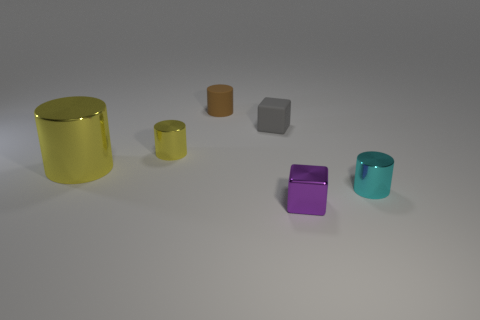Subtract 1 cylinders. How many cylinders are left? 3 Add 2 yellow cylinders. How many objects exist? 8 Subtract all blocks. How many objects are left? 4 Subtract 0 cyan balls. How many objects are left? 6 Subtract all tiny purple metal cylinders. Subtract all large yellow objects. How many objects are left? 5 Add 5 small gray cubes. How many small gray cubes are left? 6 Add 3 shiny cylinders. How many shiny cylinders exist? 6 